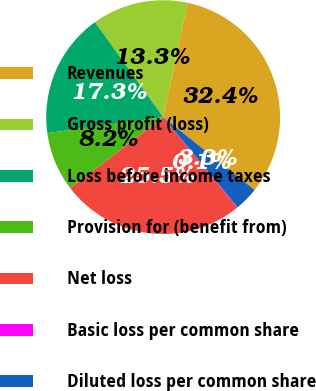<chart> <loc_0><loc_0><loc_500><loc_500><pie_chart><fcel>Revenues<fcel>Gross profit (loss)<fcel>Loss before income taxes<fcel>Provision for (benefit from)<fcel>Net loss<fcel>Basic loss per common share<fcel>Diluted loss per common share<nl><fcel>32.36%<fcel>13.26%<fcel>17.28%<fcel>8.22%<fcel>25.5%<fcel>0.08%<fcel>3.31%<nl></chart> 